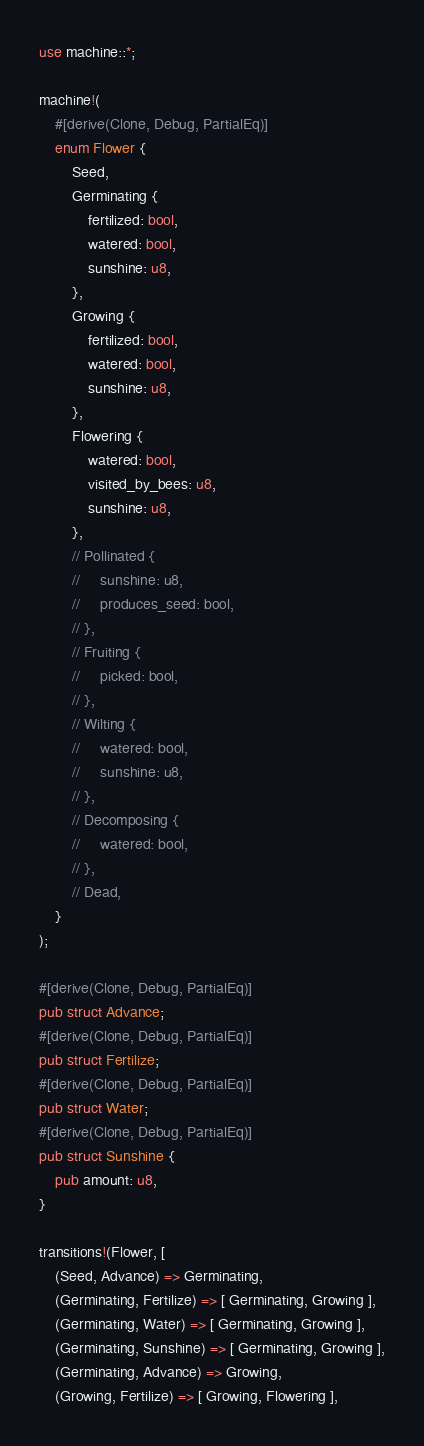<code> <loc_0><loc_0><loc_500><loc_500><_Rust_>use machine::*;

machine!(
    #[derive(Clone, Debug, PartialEq)]
    enum Flower {
        Seed,
        Germinating {
            fertilized: bool,
            watered: bool,
            sunshine: u8,
        },
        Growing {
            fertilized: bool,
            watered: bool,
            sunshine: u8,
        },
        Flowering {
            watered: bool,
            visited_by_bees: u8,
            sunshine: u8,
        },
        // Pollinated {
        //     sunshine: u8,
        //     produces_seed: bool,
        // },
        // Fruiting {
        //     picked: bool,
        // },
        // Wilting {
        //     watered: bool,
        //     sunshine: u8,
        // },
        // Decomposing {
        //     watered: bool,
        // },
        // Dead,
    }
);

#[derive(Clone, Debug, PartialEq)]
pub struct Advance;
#[derive(Clone, Debug, PartialEq)]
pub struct Fertilize;
#[derive(Clone, Debug, PartialEq)]
pub struct Water;
#[derive(Clone, Debug, PartialEq)]
pub struct Sunshine {
    pub amount: u8,
}

transitions!(Flower, [
    (Seed, Advance) => Germinating,
    (Germinating, Fertilize) => [ Germinating, Growing ],
    (Germinating, Water) => [ Germinating, Growing ],
    (Germinating, Sunshine) => [ Germinating, Growing ],
    (Germinating, Advance) => Growing,
    (Growing, Fertilize) => [ Growing, Flowering ],</code> 